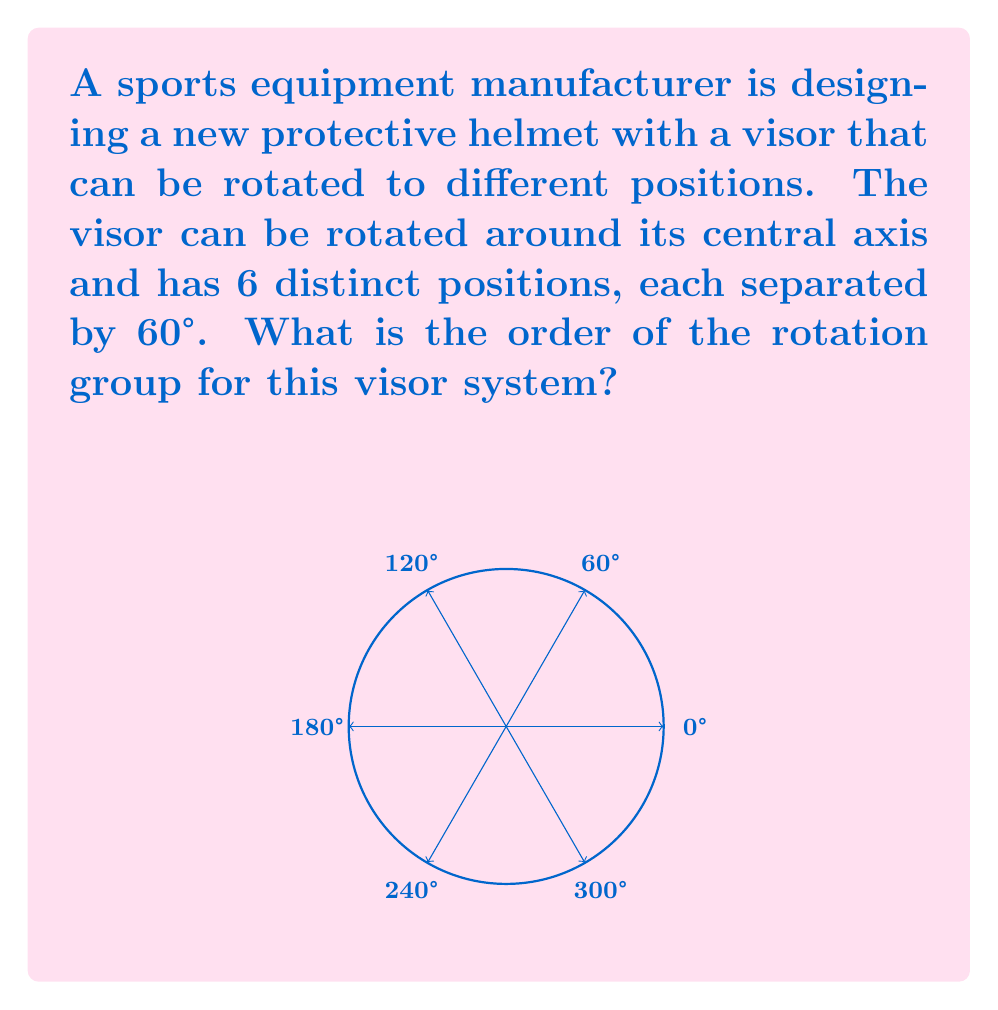Teach me how to tackle this problem. To determine the order of the rotation group for this visor system, we need to follow these steps:

1) First, let's identify the symmetries of the system:
   - The visor can be rotated by 0°, 60°, 120°, 180°, 240°, and 300°.
   - Each of these rotations brings the visor back to a valid position.

2) In group theory, these rotations form a cyclic group. The order of a cyclic group is equal to the number of distinct elements in the group.

3) Let's denote the rotation by 60° as $r$. Then, the elements of the group are:
   $$e, r, r^2, r^3, r^4, r^5$$
   where $e$ represents the identity (rotation by 0°).

4) We can verify that:
   $r^6 = e$ (rotating by 360° brings us back to the starting position)

5) Therefore, this is a cyclic group of order 6, often denoted as $C_6$ or $\mathbb{Z}_6$.

6) In general, for a system with $n$ equally spaced positions, the order of the rotation group would be $n$.

Thus, the order of the rotation group for this visor system is 6.
Answer: 6 